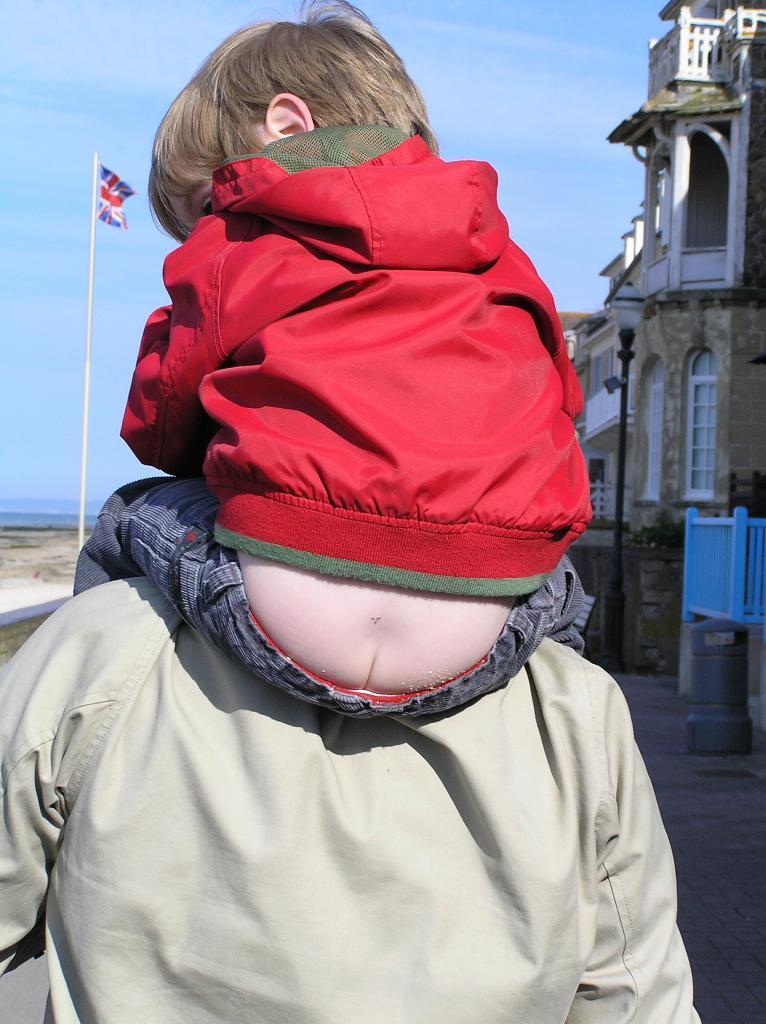Could you give a brief overview of what you see in this image? In this image I see a person and I see a child who is on that person and I see that the child is wearing red color jacket and blue jeans. In the background I see the buildings and I see the flag which is of red and blue in color and this flag is on this pole and I see the sky. 